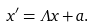Convert formula to latex. <formula><loc_0><loc_0><loc_500><loc_500>x ^ { \prime } = \Lambda x + a .</formula> 